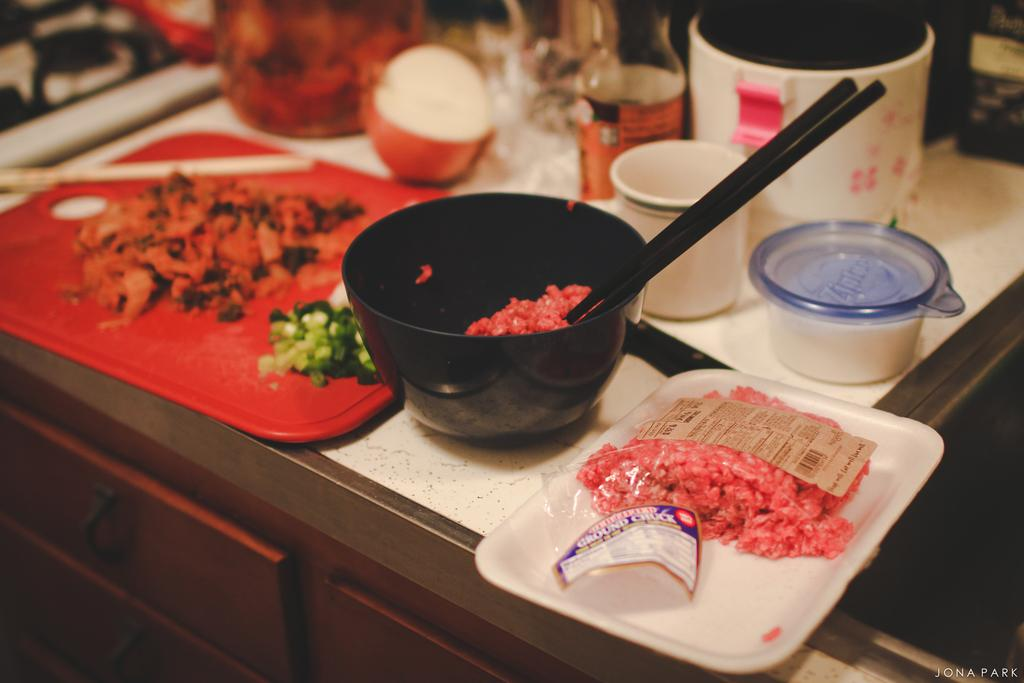What objects are present in the image that can hold food or liquids? There are bowls and a tray in the image that can hold food or liquids. What other items can be seen in the image related to serving or storing food? There are containers in the image. What can be found inside the bowls, tray, or containers? Food items are present in the image. Is there any additional information about the image that is not directly related to the objects or food? Yes, there is a watermark visible on the bottom right of the image, and the top part of the image is slightly blurred. What type of weather can be seen in the image? There is no weather visible in the image, as it is focused on bowls, a tray, containers, and food items. Can you describe the duck that is present in the image? There is no duck present in the image. 